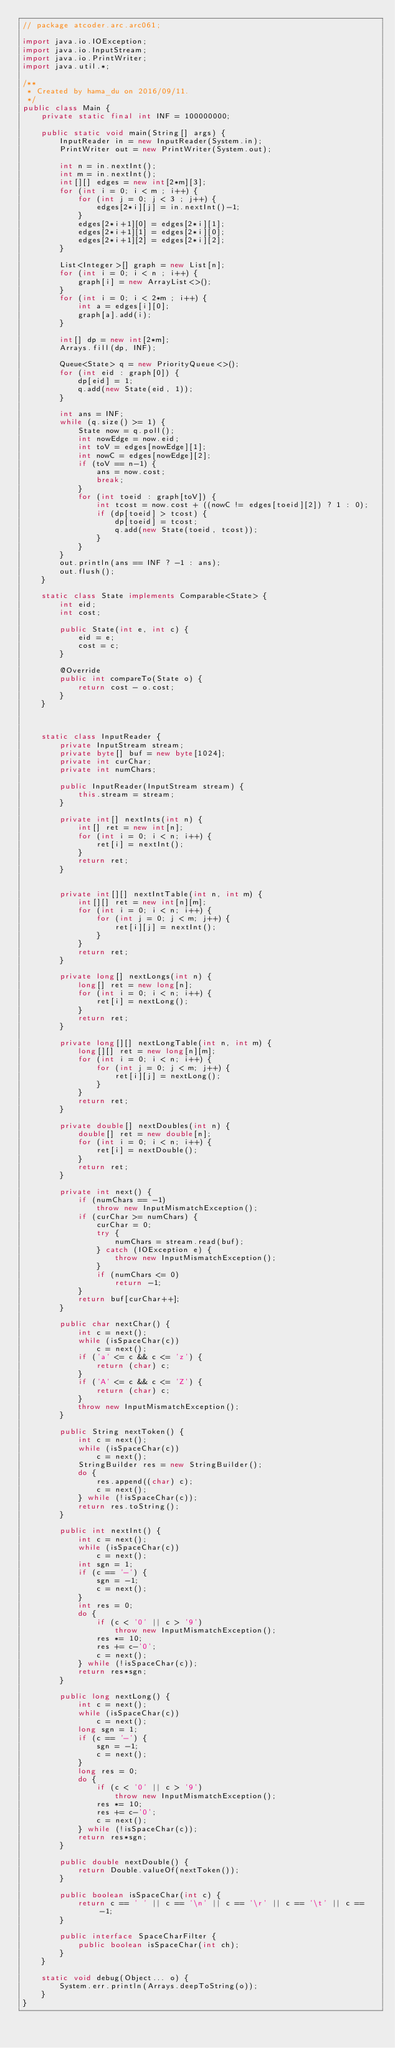Convert code to text. <code><loc_0><loc_0><loc_500><loc_500><_Java_>// package atcoder.arc.arc061;

import java.io.IOException;
import java.io.InputStream;
import java.io.PrintWriter;
import java.util.*;

/**
 * Created by hama_du on 2016/09/11.
 */
public class Main {
    private static final int INF = 100000000;

    public static void main(String[] args) {
        InputReader in = new InputReader(System.in);
        PrintWriter out = new PrintWriter(System.out);

        int n = in.nextInt();
        int m = in.nextInt();
        int[][] edges = new int[2*m][3];
        for (int i = 0; i < m ; i++) {
            for (int j = 0; j < 3 ; j++) {
                edges[2*i][j] = in.nextInt()-1;
            }
            edges[2*i+1][0] = edges[2*i][1];
            edges[2*i+1][1] = edges[2*i][0];
            edges[2*i+1][2] = edges[2*i][2];
        }

        List<Integer>[] graph = new List[n];
        for (int i = 0; i < n ; i++) {
            graph[i] = new ArrayList<>();
        }
        for (int i = 0; i < 2*m ; i++) {
            int a = edges[i][0];
            graph[a].add(i);
        }

        int[] dp = new int[2*m];
        Arrays.fill(dp, INF);

        Queue<State> q = new PriorityQueue<>();
        for (int eid : graph[0]) {
            dp[eid] = 1;
            q.add(new State(eid, 1));
        }

        int ans = INF;
        while (q.size() >= 1) {
            State now = q.poll();
            int nowEdge = now.eid;
            int toV = edges[nowEdge][1];
            int nowC = edges[nowEdge][2];
            if (toV == n-1) {
                ans = now.cost;
                break;
            }
            for (int toeid : graph[toV]) {
                int tcost = now.cost + ((nowC != edges[toeid][2]) ? 1 : 0);
                if (dp[toeid] > tcost) {
                    dp[toeid] = tcost;
                    q.add(new State(toeid, tcost));
                }
            }
        }
        out.println(ans == INF ? -1 : ans);
        out.flush();
    }

    static class State implements Comparable<State> {
        int eid;
        int cost;

        public State(int e, int c) {
            eid = e;
            cost = c;
        }

        @Override
        public int compareTo(State o) {
            return cost - o.cost;
        }
    }



    static class InputReader {
        private InputStream stream;
        private byte[] buf = new byte[1024];
        private int curChar;
        private int numChars;

        public InputReader(InputStream stream) {
            this.stream = stream;
        }

        private int[] nextInts(int n) {
            int[] ret = new int[n];
            for (int i = 0; i < n; i++) {
                ret[i] = nextInt();
            }
            return ret;
        }


        private int[][] nextIntTable(int n, int m) {
            int[][] ret = new int[n][m];
            for (int i = 0; i < n; i++) {
                for (int j = 0; j < m; j++) {
                    ret[i][j] = nextInt();
                }
            }
            return ret;
        }

        private long[] nextLongs(int n) {
            long[] ret = new long[n];
            for (int i = 0; i < n; i++) {
                ret[i] = nextLong();
            }
            return ret;
        }

        private long[][] nextLongTable(int n, int m) {
            long[][] ret = new long[n][m];
            for (int i = 0; i < n; i++) {
                for (int j = 0; j < m; j++) {
                    ret[i][j] = nextLong();
                }
            }
            return ret;
        }

        private double[] nextDoubles(int n) {
            double[] ret = new double[n];
            for (int i = 0; i < n; i++) {
                ret[i] = nextDouble();
            }
            return ret;
        }

        private int next() {
            if (numChars == -1)
                throw new InputMismatchException();
            if (curChar >= numChars) {
                curChar = 0;
                try {
                    numChars = stream.read(buf);
                } catch (IOException e) {
                    throw new InputMismatchException();
                }
                if (numChars <= 0)
                    return -1;
            }
            return buf[curChar++];
        }

        public char nextChar() {
            int c = next();
            while (isSpaceChar(c))
                c = next();
            if ('a' <= c && c <= 'z') {
                return (char) c;
            }
            if ('A' <= c && c <= 'Z') {
                return (char) c;
            }
            throw new InputMismatchException();
        }

        public String nextToken() {
            int c = next();
            while (isSpaceChar(c))
                c = next();
            StringBuilder res = new StringBuilder();
            do {
                res.append((char) c);
                c = next();
            } while (!isSpaceChar(c));
            return res.toString();
        }

        public int nextInt() {
            int c = next();
            while (isSpaceChar(c))
                c = next();
            int sgn = 1;
            if (c == '-') {
                sgn = -1;
                c = next();
            }
            int res = 0;
            do {
                if (c < '0' || c > '9')
                    throw new InputMismatchException();
                res *= 10;
                res += c-'0';
                c = next();
            } while (!isSpaceChar(c));
            return res*sgn;
        }

        public long nextLong() {
            int c = next();
            while (isSpaceChar(c))
                c = next();
            long sgn = 1;
            if (c == '-') {
                sgn = -1;
                c = next();
            }
            long res = 0;
            do {
                if (c < '0' || c > '9')
                    throw new InputMismatchException();
                res *= 10;
                res += c-'0';
                c = next();
            } while (!isSpaceChar(c));
            return res*sgn;
        }

        public double nextDouble() {
            return Double.valueOf(nextToken());
        }

        public boolean isSpaceChar(int c) {
            return c == ' ' || c == '\n' || c == '\r' || c == '\t' || c == -1;
        }

        public interface SpaceCharFilter {
            public boolean isSpaceChar(int ch);
        }
    }

    static void debug(Object... o) {
        System.err.println(Arrays.deepToString(o));
    }
}
</code> 